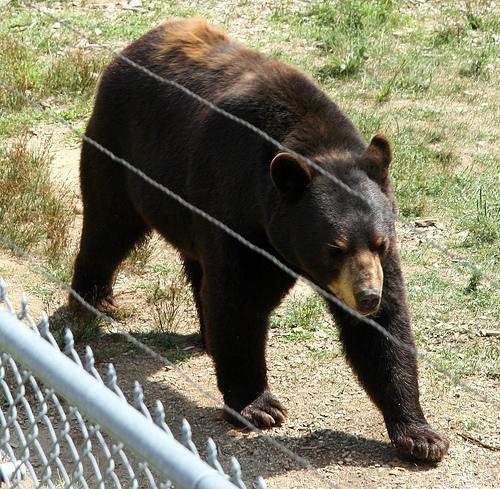How many humans are visible?
Give a very brief answer. 0. 